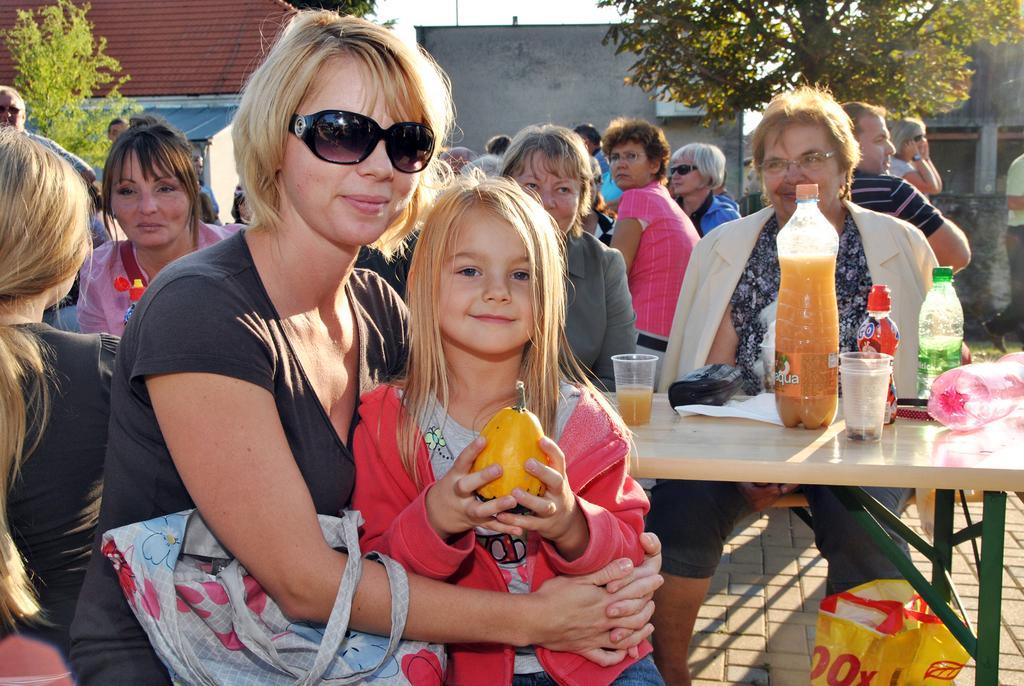Describe this image in one or two sentences. This image consists of so many people. There are buildings on the top and trees on the top. In the middle there is table, on that table there are cold drink ,glasses, Water bottles, tissues. There are people sitting near the tables. The person who is in front is wearing black dress with goggles and she also has bag. She hold a kid, she is wearing pink color dress. She has a fruit in her hand. 